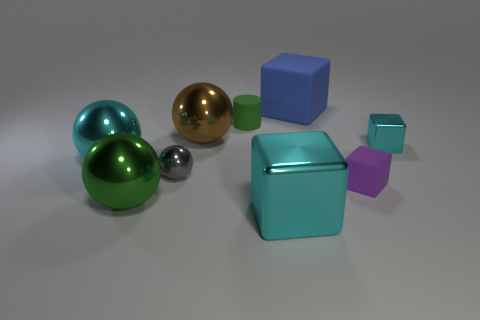Could you explain the perspective and composition of the objects in the image? The composition employs a mix of geometric shapes spread across the frame, creating a balanced yet dynamic arrangement. The perspective is such that the objects are presented in a somewhat isometric view, with the larger objects towards the back and the smaller ones towards the front, arguably to create a sense of depth and scale. 